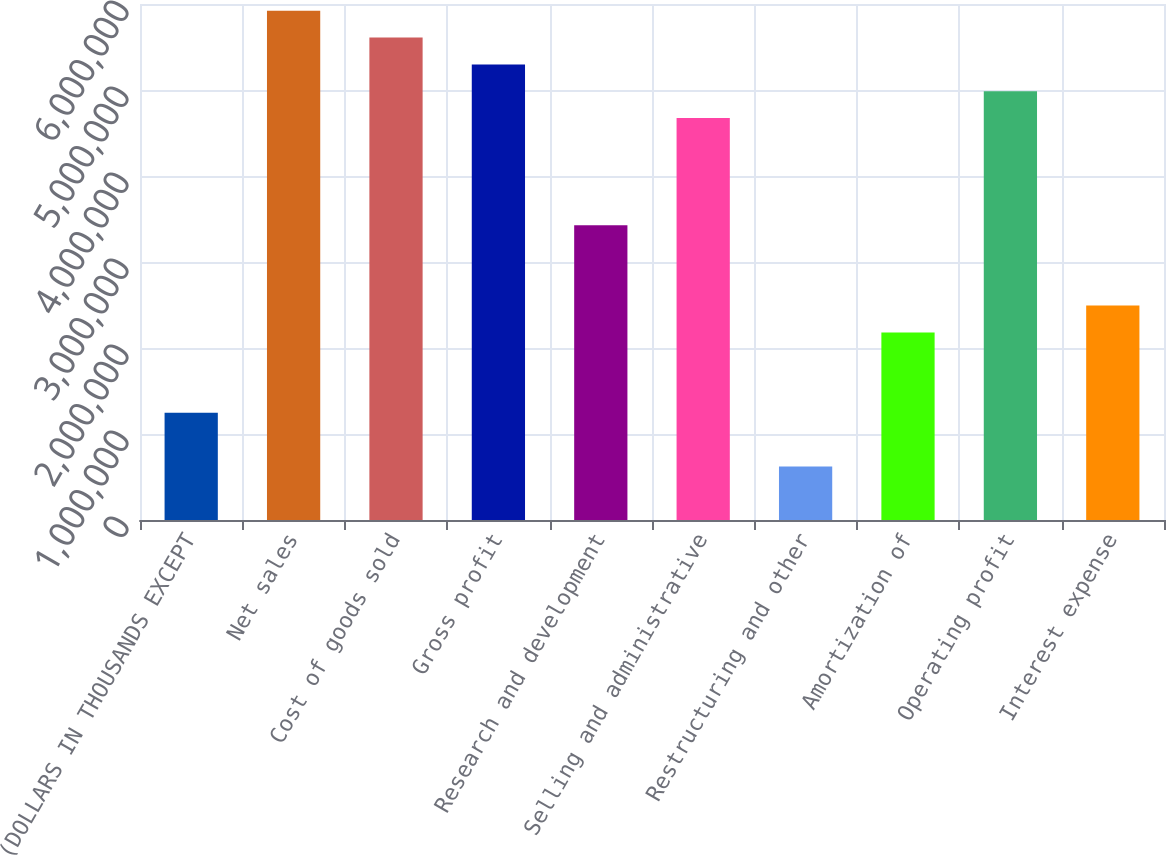<chart> <loc_0><loc_0><loc_500><loc_500><bar_chart><fcel>(DOLLARS IN THOUSANDS EXCEPT<fcel>Net sales<fcel>Cost of goods sold<fcel>Gross profit<fcel>Research and development<fcel>Selling and administrative<fcel>Restructuring and other<fcel>Amortization of<fcel>Operating profit<fcel>Interest expense<nl><fcel>1.24654e+06<fcel>5.92106e+06<fcel>5.60943e+06<fcel>5.29779e+06<fcel>3.42798e+06<fcel>4.67452e+06<fcel>623274<fcel>2.18145e+06<fcel>4.98616e+06<fcel>2.49308e+06<nl></chart> 